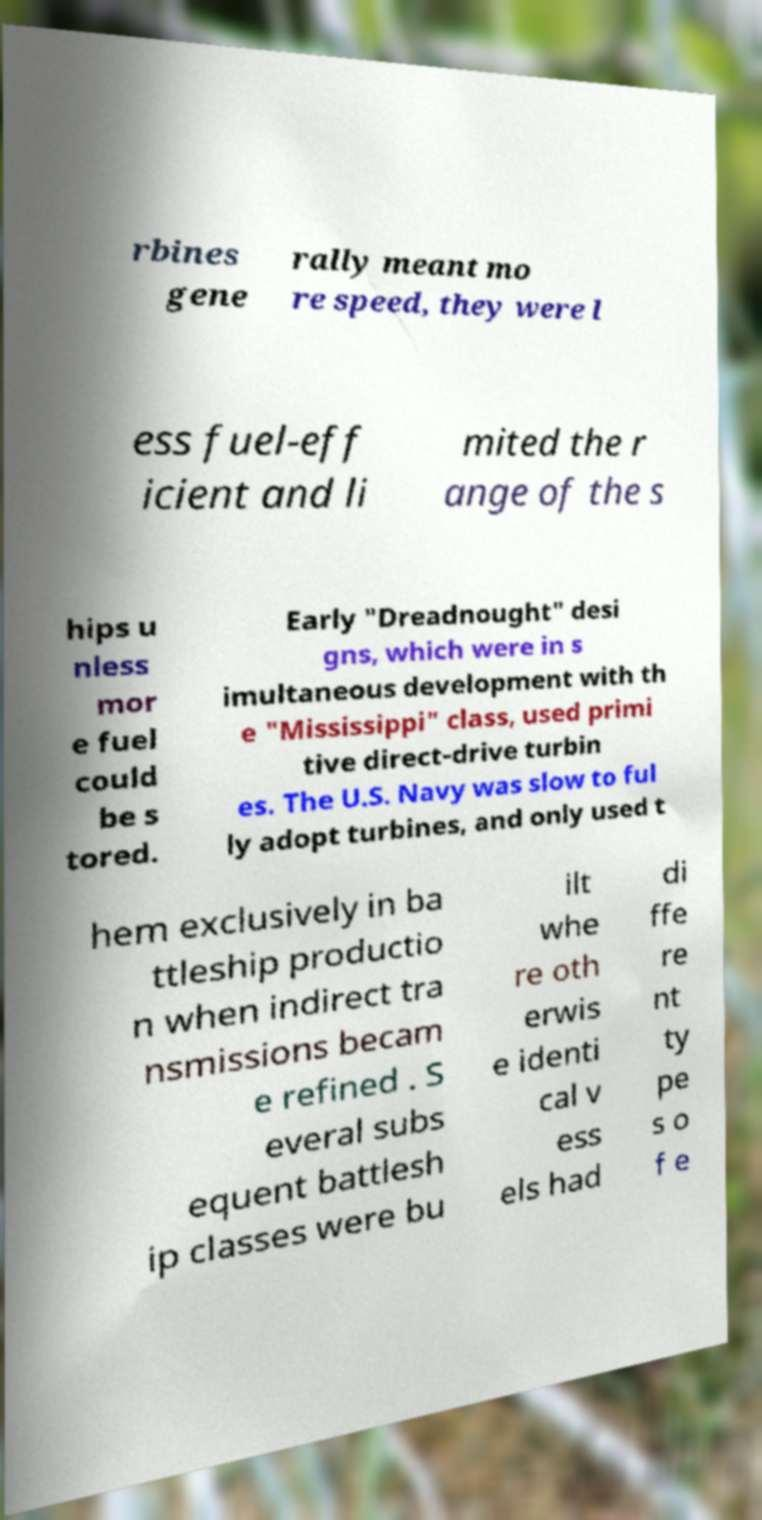Could you assist in decoding the text presented in this image and type it out clearly? rbines gene rally meant mo re speed, they were l ess fuel-eff icient and li mited the r ange of the s hips u nless mor e fuel could be s tored. Early "Dreadnought" desi gns, which were in s imultaneous development with th e "Mississippi" class, used primi tive direct-drive turbin es. The U.S. Navy was slow to ful ly adopt turbines, and only used t hem exclusively in ba ttleship productio n when indirect tra nsmissions becam e refined . S everal subs equent battlesh ip classes were bu ilt whe re oth erwis e identi cal v ess els had di ffe re nt ty pe s o f e 